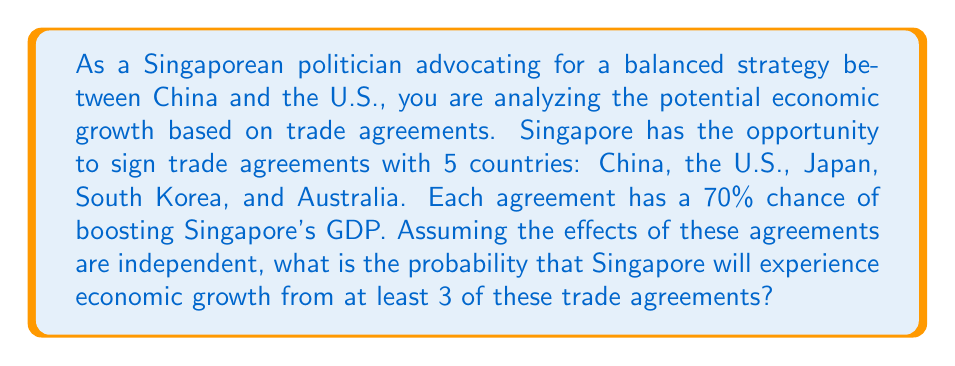Help me with this question. To solve this problem, we can use the binomial probability distribution. Let's break it down step-by-step:

1) We have 5 independent trials (trade agreements), each with a success probability of 70% or 0.7.

2) We want to find the probability of at least 3 successes, which means we need to calculate P(X ≥ 3), where X is the number of successful agreements.

3) This is equivalent to 1 - P(X < 3) = 1 - [P(X = 0) + P(X = 1) + P(X = 2)].

4) The probability mass function for a binomial distribution is:

   $$P(X = k) = \binom{n}{k} p^k (1-p)^{n-k}$$

   where n is the number of trials, k is the number of successes, p is the probability of success.

5) Let's calculate each term:

   P(X = 0) = $\binom{5}{0} (0.7)^0 (0.3)^5 = 1 \cdot 1 \cdot 0.00243 = 0.00243$

   P(X = 1) = $\binom{5}{1} (0.7)^1 (0.3)^4 = 5 \cdot 0.7 \cdot 0.0081 = 0.02835$

   P(X = 2) = $\binom{5}{2} (0.7)^2 (0.3)^3 = 10 \cdot 0.49 \cdot 0.027 = 0.13230$

6) Now, we can calculate P(X < 3):

   P(X < 3) = 0.00243 + 0.02835 + 0.13230 = 0.16308

7) Finally, we can calculate P(X ≥ 3):

   P(X ≥ 3) = 1 - P(X < 3) = 1 - 0.16308 = 0.83692
Answer: The probability that Singapore will experience economic growth from at least 3 of these trade agreements is approximately 0.83692 or 83.69%. 